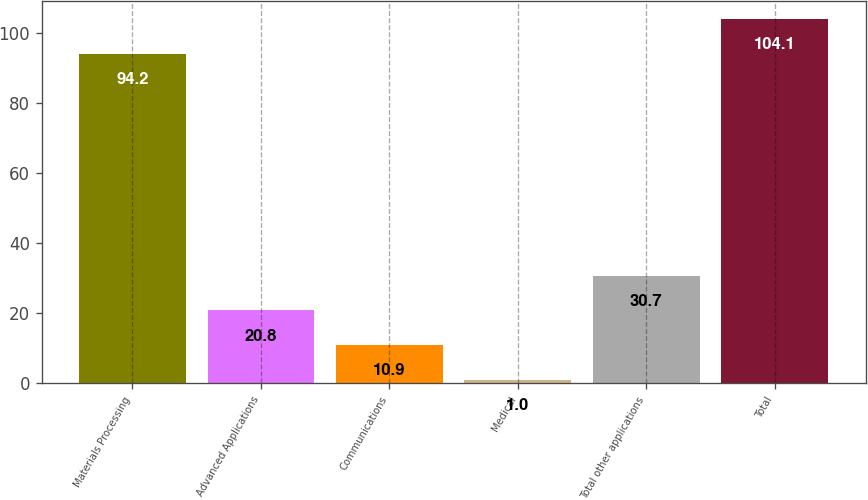Convert chart to OTSL. <chart><loc_0><loc_0><loc_500><loc_500><bar_chart><fcel>Materials Processing<fcel>Advanced Applications<fcel>Communications<fcel>Medical<fcel>Total other applications<fcel>Total<nl><fcel>94.2<fcel>20.8<fcel>10.9<fcel>1<fcel>30.7<fcel>104.1<nl></chart> 